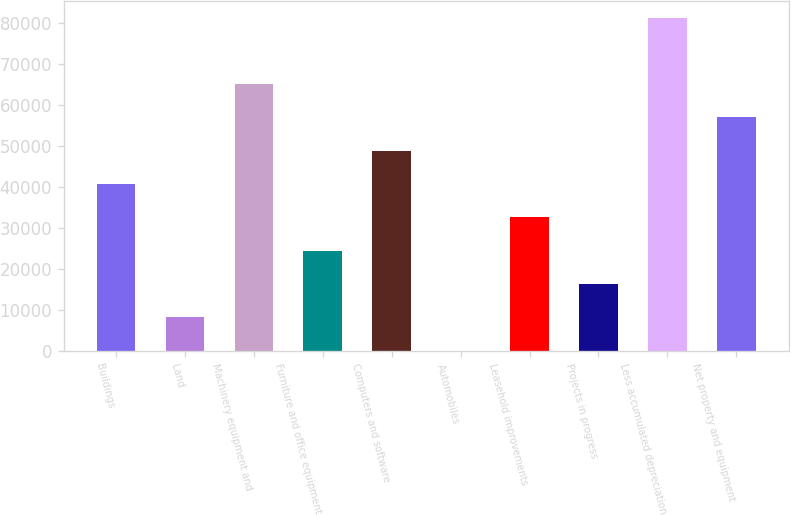Convert chart. <chart><loc_0><loc_0><loc_500><loc_500><bar_chart><fcel>Buildings<fcel>Land<fcel>Machinery equipment and<fcel>Furniture and office equipment<fcel>Computers and software<fcel>Automobiles<fcel>Leasehold improvements<fcel>Projects in progress<fcel>Less accumulated depreciation<fcel>Net property and equipment<nl><fcel>40623<fcel>8135.8<fcel>64988.4<fcel>24379.4<fcel>48744.8<fcel>14<fcel>32501.2<fcel>16257.6<fcel>81232<fcel>56866.6<nl></chart> 